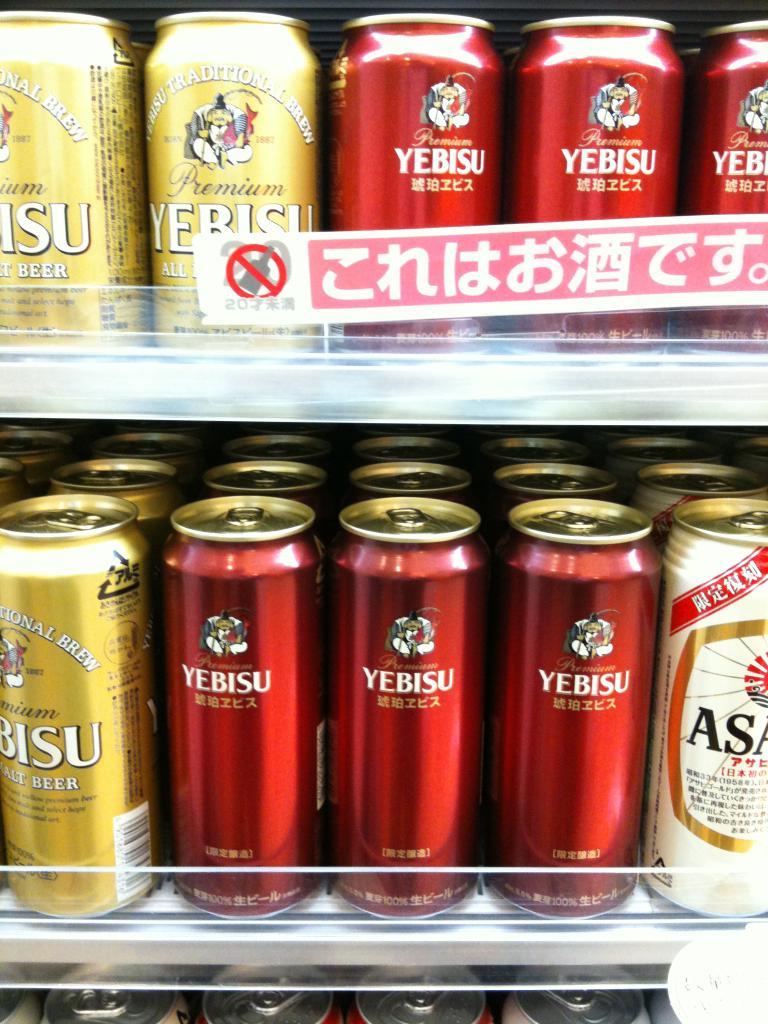What kind of beverages are these?
Offer a very short reply. Yebisu. 